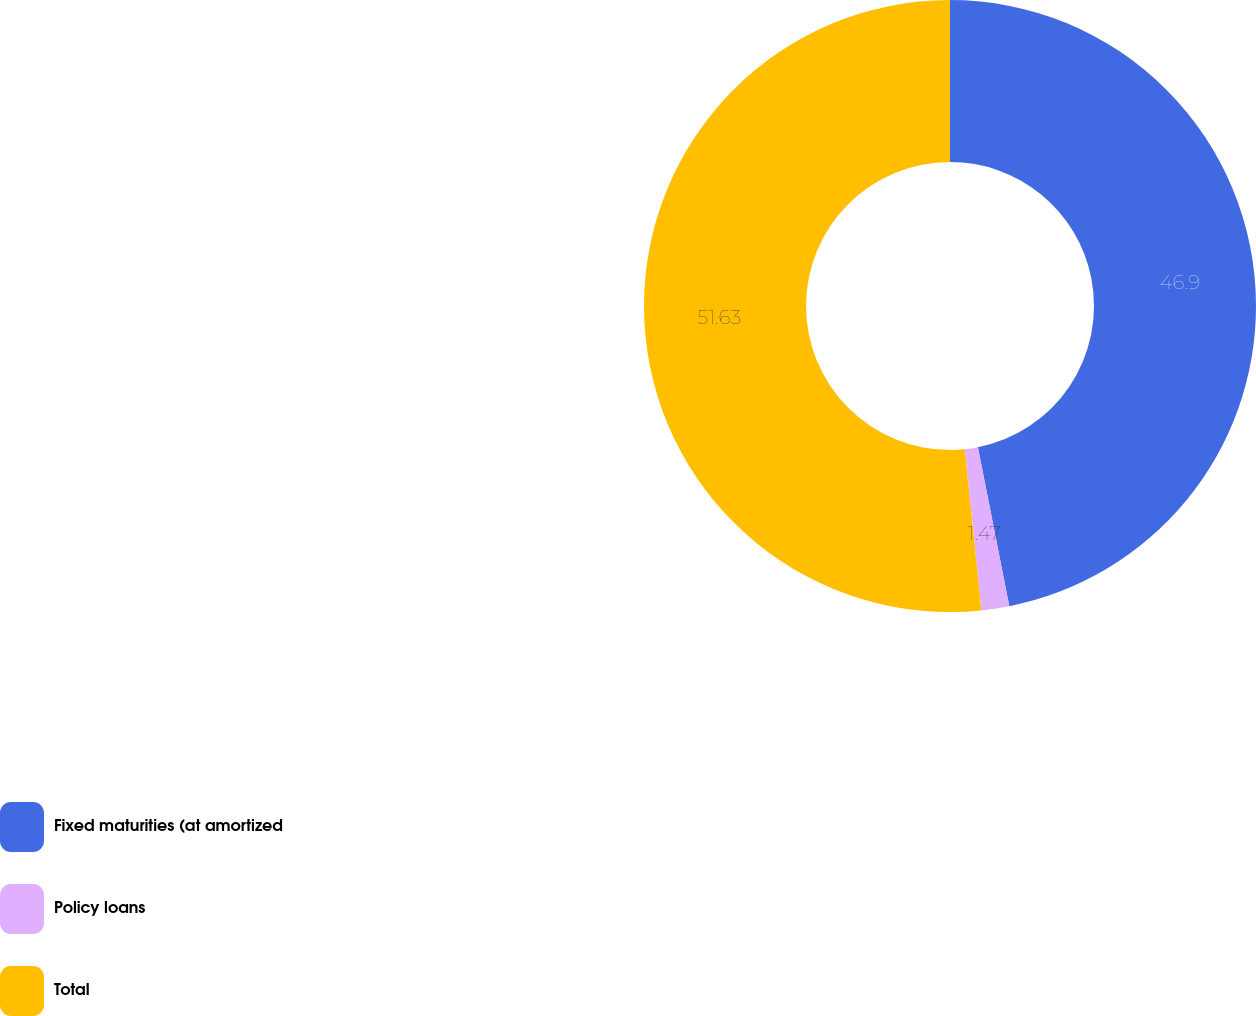<chart> <loc_0><loc_0><loc_500><loc_500><pie_chart><fcel>Fixed maturities (at amortized<fcel>Policy loans<fcel>Total<nl><fcel>46.9%<fcel>1.47%<fcel>51.64%<nl></chart> 